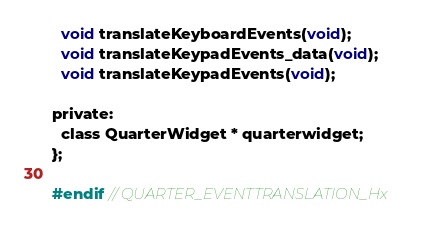<code> <loc_0><loc_0><loc_500><loc_500><_C_>  void translateKeyboardEvents(void);
  void translateKeypadEvents_data(void);
  void translateKeypadEvents(void);

private:
  class QuarterWidget * quarterwidget;
};

#endif // QUARTER_EVENTTRANSLATION_Hx
</code> 